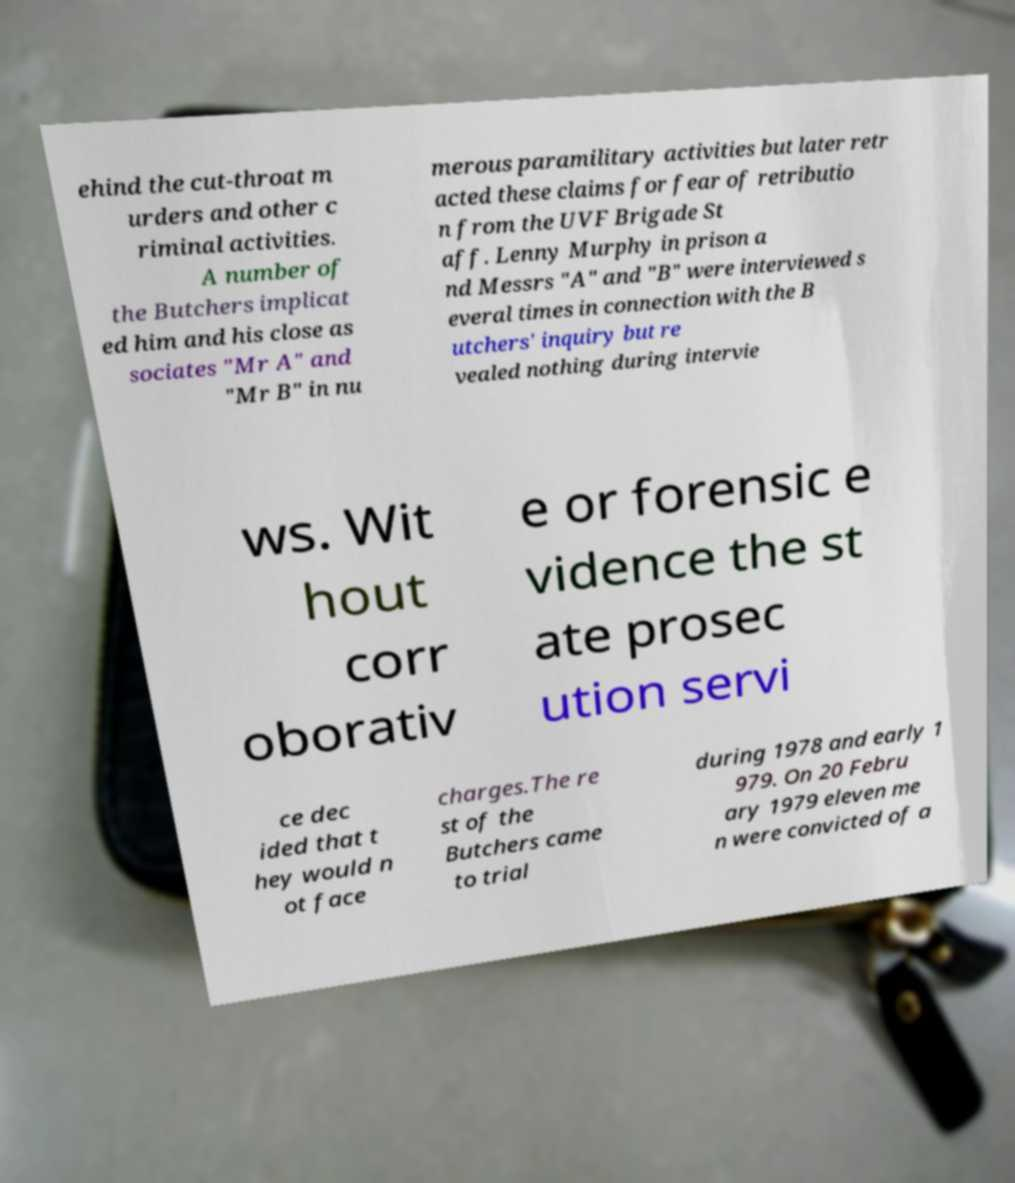There's text embedded in this image that I need extracted. Can you transcribe it verbatim? ehind the cut-throat m urders and other c riminal activities. A number of the Butchers implicat ed him and his close as sociates "Mr A" and "Mr B" in nu merous paramilitary activities but later retr acted these claims for fear of retributio n from the UVF Brigade St aff. Lenny Murphy in prison a nd Messrs "A" and "B" were interviewed s everal times in connection with the B utchers' inquiry but re vealed nothing during intervie ws. Wit hout corr oborativ e or forensic e vidence the st ate prosec ution servi ce dec ided that t hey would n ot face charges.The re st of the Butchers came to trial during 1978 and early 1 979. On 20 Febru ary 1979 eleven me n were convicted of a 